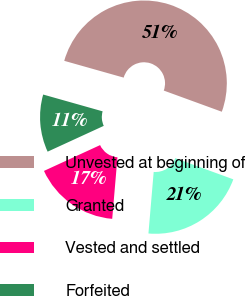<chart> <loc_0><loc_0><loc_500><loc_500><pie_chart><fcel>Unvested at beginning of<fcel>Granted<fcel>Vested and settled<fcel>Forfeited<nl><fcel>51.19%<fcel>20.79%<fcel>16.79%<fcel>11.24%<nl></chart> 